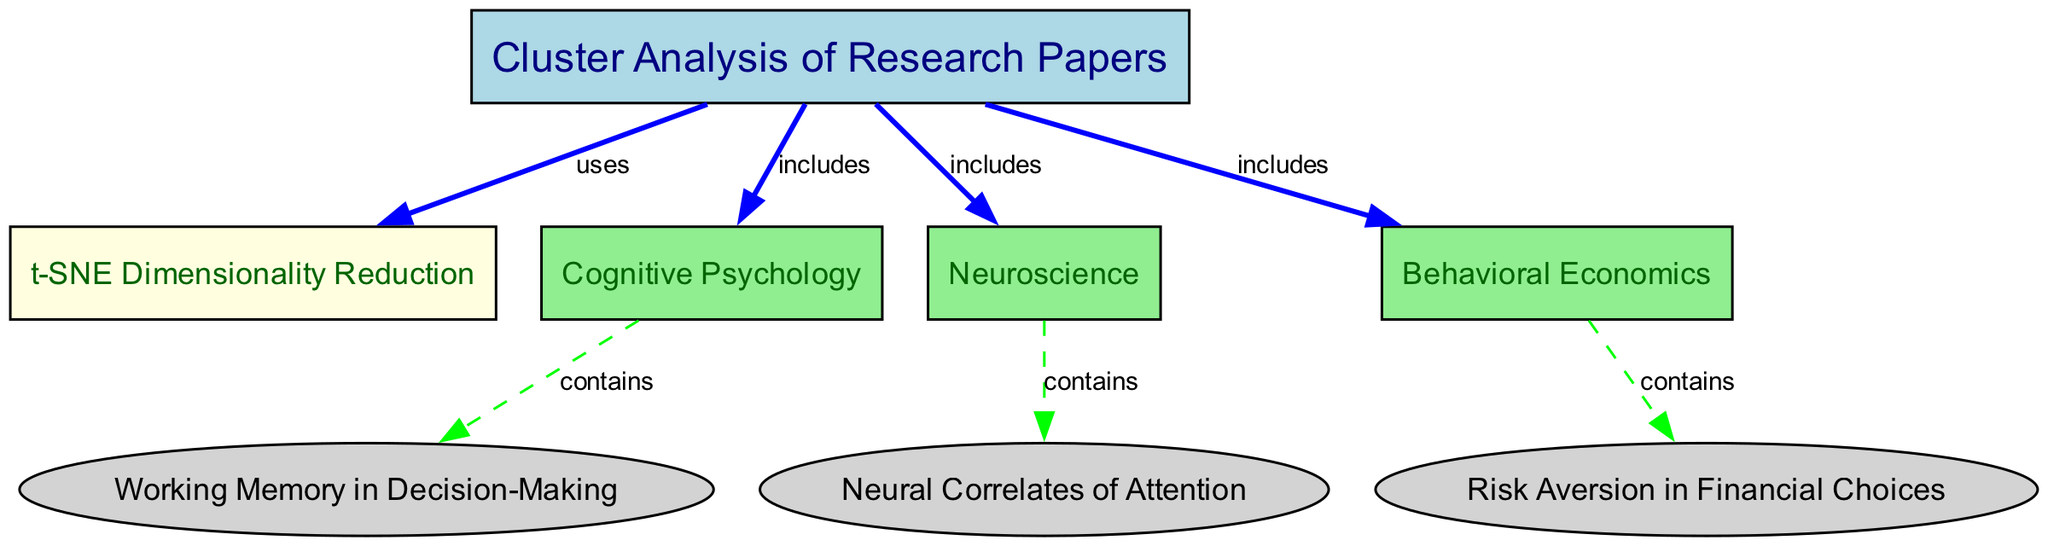What is the primary method used for dimensionality reduction in this analysis? The diagram shows an edge labeled "uses" connecting the "Cluster Analysis of Research Papers" node to the "t-SNE Dimensionality Reduction" node, indicating that t-SNE is the method used.
Answer: t-SNE Dimensionality Reduction How many subfields are included in the cluster analysis? There are three edges labeled "includes" going from the "Cluster Analysis of Research Papers" node to the subfield nodes, indicating three distinct subfields.
Answer: 3 What is the label of the paper associated with Cognitive Psychology? The edge labeled "contains" connecting the "Cognitive Psychology" subfield to the "Working Memory in Decision-Making" paper specifies this relationship, identifying the relevant paper.
Answer: Working Memory in Decision-Making Which subfield does the paper "Neural Correlates of Attention" belong to? The diagram depicts an edge labeled "contains" from the "Neuroscience" subfield to the "Neural Correlates of Attention" paper, indicating the relationship of the paper to the Neuroscience field.
Answer: Neuroscience What color represents the subfield of Behavioral Economics? The "Behavioral Economics" node is filled with light green color according to the diagram's design for subfields, which all share this color scheme.
Answer: light green How many edges are connected to the "Cluster Analysis of Research Papers" node? The center node has four outgoing edges, as seen in the diagram connecting it to the t-SNE method and the three subfields.
Answer: 4 What type of diagram is this? The context and connections displayed suggest that it is a cluster analysis diagram emphasizing research papers and their relationships, specifically in the field of Machine Learning.
Answer: Cluster Analysis Diagram Which paper belongs to the subfield of Behavioral Economics? The "Risk Aversion in Financial Choices" paper is directly connected to the "Behavioral Economics" subfield via the "contains" edge shown in the diagram.
Answer: Risk Aversion in Financial Choices 